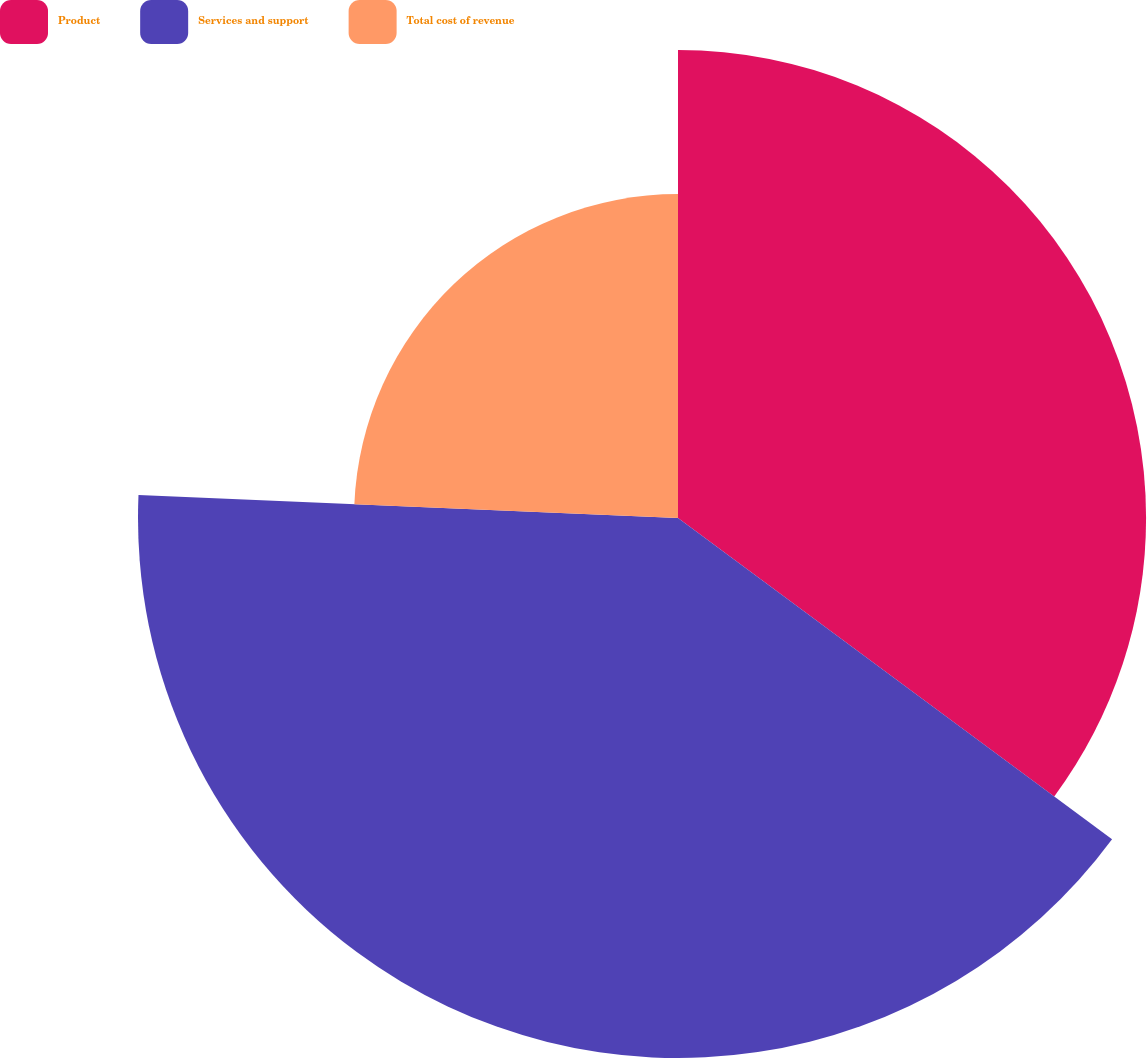<chart> <loc_0><loc_0><loc_500><loc_500><pie_chart><fcel>Product<fcel>Services and support<fcel>Total cost of revenue<nl><fcel>35.14%<fcel>40.54%<fcel>24.32%<nl></chart> 